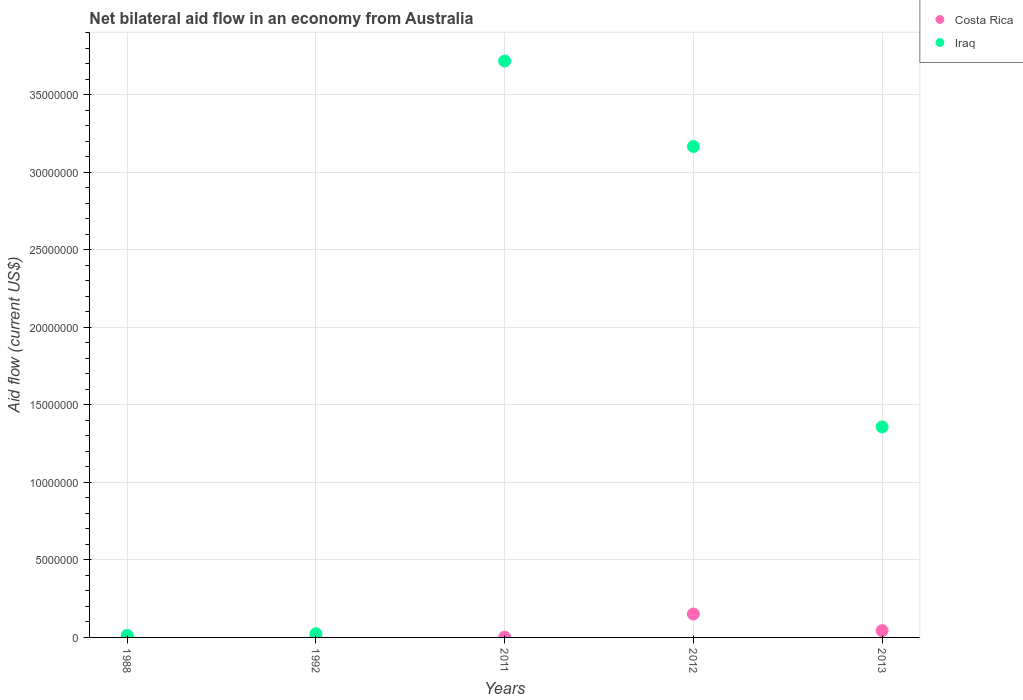How many different coloured dotlines are there?
Offer a terse response. 2. Is the number of dotlines equal to the number of legend labels?
Ensure brevity in your answer.  Yes. What is the net bilateral aid flow in Iraq in 2012?
Your answer should be compact. 3.17e+07. Across all years, what is the maximum net bilateral aid flow in Iraq?
Offer a terse response. 3.72e+07. Across all years, what is the minimum net bilateral aid flow in Costa Rica?
Provide a succinct answer. 2.00e+04. In which year was the net bilateral aid flow in Iraq maximum?
Your answer should be compact. 2011. In which year was the net bilateral aid flow in Iraq minimum?
Ensure brevity in your answer.  1988. What is the total net bilateral aid flow in Costa Rica in the graph?
Offer a terse response. 2.01e+06. What is the difference between the net bilateral aid flow in Iraq in 1988 and that in 2011?
Offer a terse response. -3.70e+07. What is the difference between the net bilateral aid flow in Costa Rica in 2011 and the net bilateral aid flow in Iraq in 2013?
Provide a short and direct response. -1.36e+07. What is the average net bilateral aid flow in Costa Rica per year?
Your answer should be very brief. 4.02e+05. In the year 2011, what is the difference between the net bilateral aid flow in Costa Rica and net bilateral aid flow in Iraq?
Offer a terse response. -3.72e+07. In how many years, is the net bilateral aid flow in Iraq greater than 28000000 US$?
Offer a terse response. 2. What is the ratio of the net bilateral aid flow in Costa Rica in 2011 to that in 2012?
Ensure brevity in your answer.  0.01. Is the difference between the net bilateral aid flow in Costa Rica in 1988 and 1992 greater than the difference between the net bilateral aid flow in Iraq in 1988 and 1992?
Ensure brevity in your answer.  Yes. What is the difference between the highest and the second highest net bilateral aid flow in Iraq?
Your response must be concise. 5.51e+06. What is the difference between the highest and the lowest net bilateral aid flow in Iraq?
Your answer should be compact. 3.70e+07. In how many years, is the net bilateral aid flow in Iraq greater than the average net bilateral aid flow in Iraq taken over all years?
Your answer should be compact. 2. Does the net bilateral aid flow in Iraq monotonically increase over the years?
Offer a very short reply. No. Are the values on the major ticks of Y-axis written in scientific E-notation?
Offer a terse response. No. What is the title of the graph?
Provide a succinct answer. Net bilateral aid flow in an economy from Australia. What is the label or title of the Y-axis?
Keep it short and to the point. Aid flow (current US$). What is the Aid flow (current US$) in Costa Rica in 1988?
Make the answer very short. 2.00e+04. What is the Aid flow (current US$) of Iraq in 1988?
Give a very brief answer. 1.30e+05. What is the Aid flow (current US$) of Iraq in 2011?
Keep it short and to the point. 3.72e+07. What is the Aid flow (current US$) in Costa Rica in 2012?
Your answer should be compact. 1.51e+06. What is the Aid flow (current US$) of Iraq in 2012?
Ensure brevity in your answer.  3.17e+07. What is the Aid flow (current US$) in Iraq in 2013?
Provide a succinct answer. 1.36e+07. Across all years, what is the maximum Aid flow (current US$) in Costa Rica?
Ensure brevity in your answer.  1.51e+06. Across all years, what is the maximum Aid flow (current US$) in Iraq?
Your response must be concise. 3.72e+07. Across all years, what is the minimum Aid flow (current US$) in Costa Rica?
Offer a terse response. 2.00e+04. What is the total Aid flow (current US$) in Costa Rica in the graph?
Make the answer very short. 2.01e+06. What is the total Aid flow (current US$) of Iraq in the graph?
Offer a very short reply. 8.28e+07. What is the difference between the Aid flow (current US$) in Iraq in 1988 and that in 2011?
Offer a very short reply. -3.70e+07. What is the difference between the Aid flow (current US$) of Costa Rica in 1988 and that in 2012?
Provide a succinct answer. -1.49e+06. What is the difference between the Aid flow (current US$) in Iraq in 1988 and that in 2012?
Offer a terse response. -3.15e+07. What is the difference between the Aid flow (current US$) of Costa Rica in 1988 and that in 2013?
Give a very brief answer. -4.20e+05. What is the difference between the Aid flow (current US$) of Iraq in 1988 and that in 2013?
Give a very brief answer. -1.34e+07. What is the difference between the Aid flow (current US$) in Iraq in 1992 and that in 2011?
Make the answer very short. -3.69e+07. What is the difference between the Aid flow (current US$) in Costa Rica in 1992 and that in 2012?
Offer a terse response. -1.49e+06. What is the difference between the Aid flow (current US$) in Iraq in 1992 and that in 2012?
Offer a very short reply. -3.14e+07. What is the difference between the Aid flow (current US$) of Costa Rica in 1992 and that in 2013?
Offer a very short reply. -4.20e+05. What is the difference between the Aid flow (current US$) of Iraq in 1992 and that in 2013?
Your answer should be very brief. -1.33e+07. What is the difference between the Aid flow (current US$) of Costa Rica in 2011 and that in 2012?
Your answer should be very brief. -1.49e+06. What is the difference between the Aid flow (current US$) in Iraq in 2011 and that in 2012?
Offer a terse response. 5.51e+06. What is the difference between the Aid flow (current US$) in Costa Rica in 2011 and that in 2013?
Your response must be concise. -4.20e+05. What is the difference between the Aid flow (current US$) of Iraq in 2011 and that in 2013?
Make the answer very short. 2.36e+07. What is the difference between the Aid flow (current US$) in Costa Rica in 2012 and that in 2013?
Offer a very short reply. 1.07e+06. What is the difference between the Aid flow (current US$) in Iraq in 2012 and that in 2013?
Keep it short and to the point. 1.81e+07. What is the difference between the Aid flow (current US$) in Costa Rica in 1988 and the Aid flow (current US$) in Iraq in 1992?
Make the answer very short. -2.20e+05. What is the difference between the Aid flow (current US$) of Costa Rica in 1988 and the Aid flow (current US$) of Iraq in 2011?
Offer a terse response. -3.72e+07. What is the difference between the Aid flow (current US$) of Costa Rica in 1988 and the Aid flow (current US$) of Iraq in 2012?
Your response must be concise. -3.16e+07. What is the difference between the Aid flow (current US$) of Costa Rica in 1988 and the Aid flow (current US$) of Iraq in 2013?
Keep it short and to the point. -1.36e+07. What is the difference between the Aid flow (current US$) of Costa Rica in 1992 and the Aid flow (current US$) of Iraq in 2011?
Offer a terse response. -3.72e+07. What is the difference between the Aid flow (current US$) of Costa Rica in 1992 and the Aid flow (current US$) of Iraq in 2012?
Give a very brief answer. -3.16e+07. What is the difference between the Aid flow (current US$) in Costa Rica in 1992 and the Aid flow (current US$) in Iraq in 2013?
Your response must be concise. -1.36e+07. What is the difference between the Aid flow (current US$) in Costa Rica in 2011 and the Aid flow (current US$) in Iraq in 2012?
Ensure brevity in your answer.  -3.16e+07. What is the difference between the Aid flow (current US$) in Costa Rica in 2011 and the Aid flow (current US$) in Iraq in 2013?
Ensure brevity in your answer.  -1.36e+07. What is the difference between the Aid flow (current US$) in Costa Rica in 2012 and the Aid flow (current US$) in Iraq in 2013?
Provide a succinct answer. -1.21e+07. What is the average Aid flow (current US$) in Costa Rica per year?
Your answer should be compact. 4.02e+05. What is the average Aid flow (current US$) in Iraq per year?
Provide a succinct answer. 1.66e+07. In the year 2011, what is the difference between the Aid flow (current US$) in Costa Rica and Aid flow (current US$) in Iraq?
Offer a terse response. -3.72e+07. In the year 2012, what is the difference between the Aid flow (current US$) in Costa Rica and Aid flow (current US$) in Iraq?
Offer a terse response. -3.02e+07. In the year 2013, what is the difference between the Aid flow (current US$) in Costa Rica and Aid flow (current US$) in Iraq?
Provide a short and direct response. -1.31e+07. What is the ratio of the Aid flow (current US$) of Costa Rica in 1988 to that in 1992?
Offer a very short reply. 1. What is the ratio of the Aid flow (current US$) in Iraq in 1988 to that in 1992?
Offer a terse response. 0.54. What is the ratio of the Aid flow (current US$) of Costa Rica in 1988 to that in 2011?
Provide a succinct answer. 1. What is the ratio of the Aid flow (current US$) of Iraq in 1988 to that in 2011?
Make the answer very short. 0. What is the ratio of the Aid flow (current US$) of Costa Rica in 1988 to that in 2012?
Ensure brevity in your answer.  0.01. What is the ratio of the Aid flow (current US$) in Iraq in 1988 to that in 2012?
Provide a succinct answer. 0. What is the ratio of the Aid flow (current US$) of Costa Rica in 1988 to that in 2013?
Provide a short and direct response. 0.05. What is the ratio of the Aid flow (current US$) of Iraq in 1988 to that in 2013?
Your answer should be very brief. 0.01. What is the ratio of the Aid flow (current US$) in Costa Rica in 1992 to that in 2011?
Give a very brief answer. 1. What is the ratio of the Aid flow (current US$) of Iraq in 1992 to that in 2011?
Offer a terse response. 0.01. What is the ratio of the Aid flow (current US$) of Costa Rica in 1992 to that in 2012?
Offer a terse response. 0.01. What is the ratio of the Aid flow (current US$) of Iraq in 1992 to that in 2012?
Keep it short and to the point. 0.01. What is the ratio of the Aid flow (current US$) in Costa Rica in 1992 to that in 2013?
Your response must be concise. 0.05. What is the ratio of the Aid flow (current US$) in Iraq in 1992 to that in 2013?
Your answer should be compact. 0.02. What is the ratio of the Aid flow (current US$) of Costa Rica in 2011 to that in 2012?
Offer a very short reply. 0.01. What is the ratio of the Aid flow (current US$) in Iraq in 2011 to that in 2012?
Your answer should be compact. 1.17. What is the ratio of the Aid flow (current US$) of Costa Rica in 2011 to that in 2013?
Provide a succinct answer. 0.05. What is the ratio of the Aid flow (current US$) in Iraq in 2011 to that in 2013?
Offer a terse response. 2.74. What is the ratio of the Aid flow (current US$) in Costa Rica in 2012 to that in 2013?
Make the answer very short. 3.43. What is the ratio of the Aid flow (current US$) of Iraq in 2012 to that in 2013?
Provide a short and direct response. 2.33. What is the difference between the highest and the second highest Aid flow (current US$) in Costa Rica?
Give a very brief answer. 1.07e+06. What is the difference between the highest and the second highest Aid flow (current US$) in Iraq?
Your response must be concise. 5.51e+06. What is the difference between the highest and the lowest Aid flow (current US$) of Costa Rica?
Your answer should be very brief. 1.49e+06. What is the difference between the highest and the lowest Aid flow (current US$) of Iraq?
Your answer should be compact. 3.70e+07. 